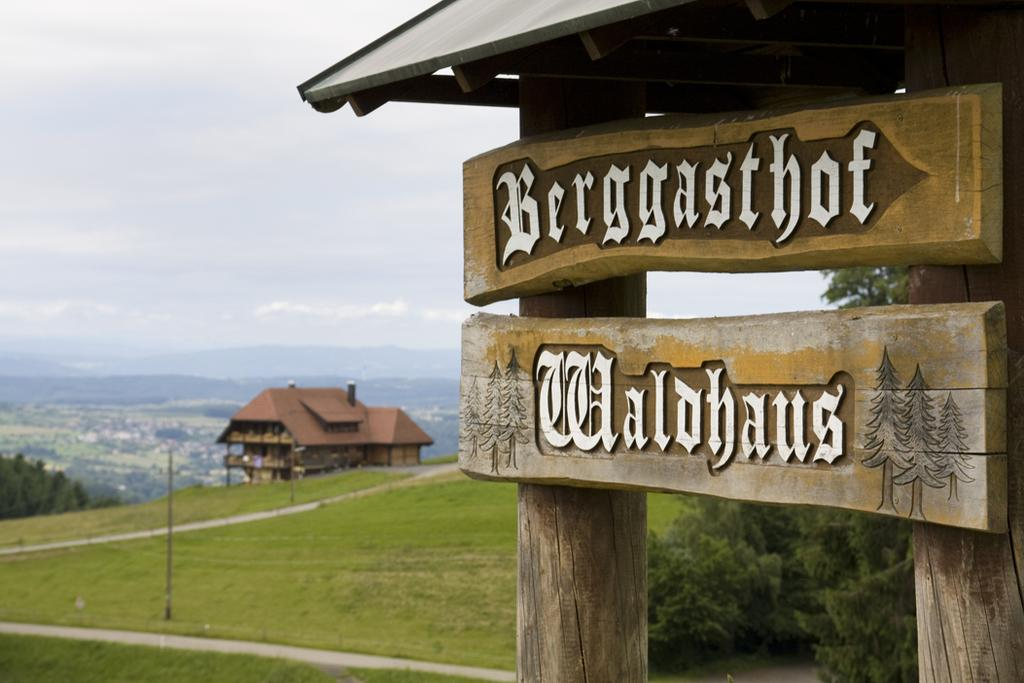What type of vegetation can be seen in the image? There are trees in the image. What type of structure is present in the image? There is a shed in the image. What is located on the right side of the image? There is a board on the right side of the image. What can be seen in the distance in the image? There are hills visible in the background of the image. What is visible above the trees and hills in the image? The sky is visible in the background of the image. Where is the mark that controls the bed in the image? There is no mark or bed present in the image. What type of control system is used for the trees in the image? The trees in the image are natural vegetation and do not require any control system. 